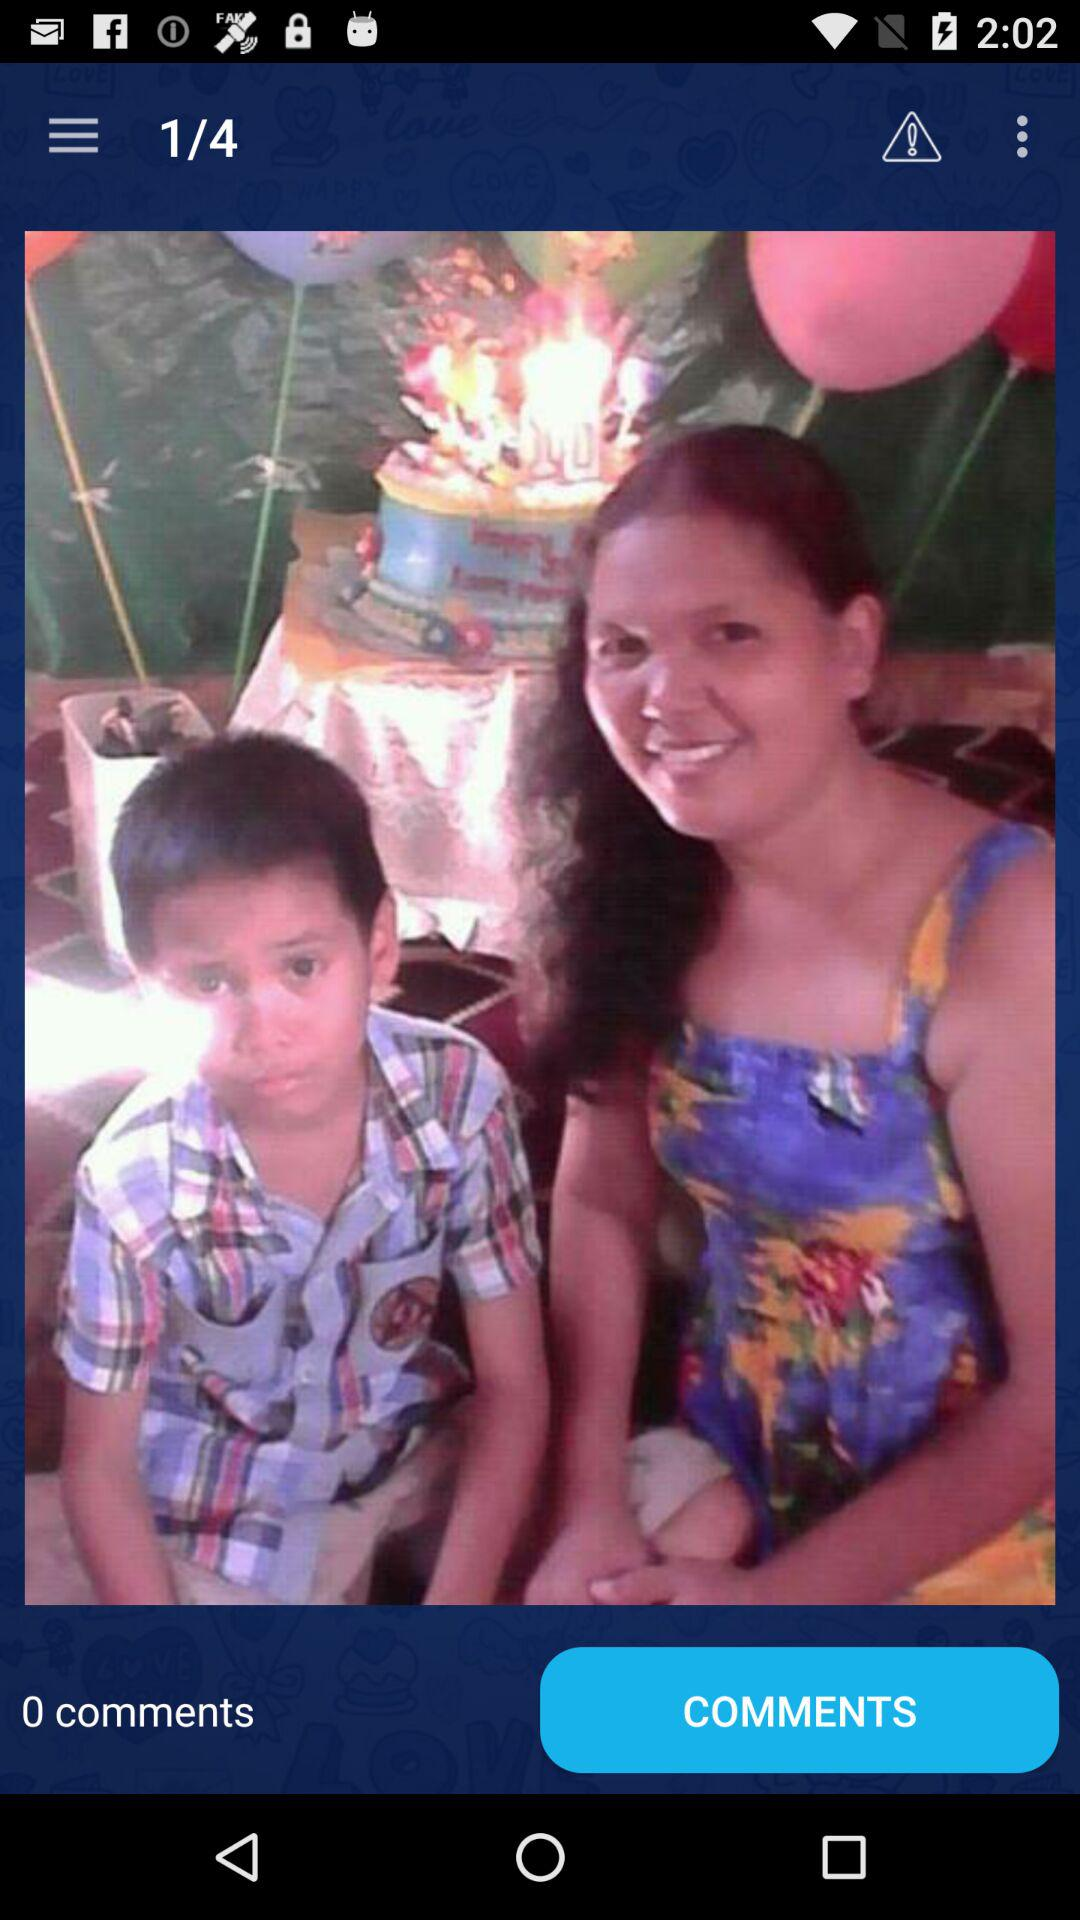At which image number are we right now? You are at image number 1. 